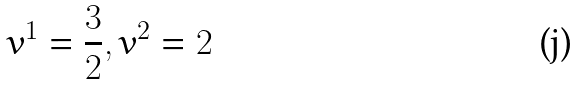Convert formula to latex. <formula><loc_0><loc_0><loc_500><loc_500>v ^ { 1 } = \frac { 3 } { 2 } , v ^ { 2 } = 2</formula> 